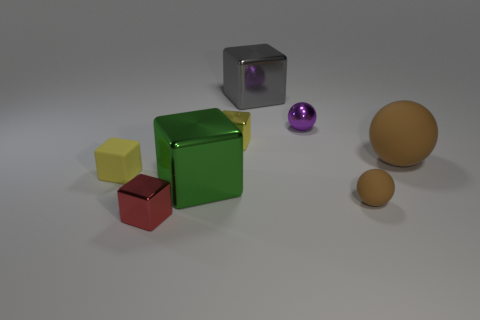Subtract 2 cubes. How many cubes are left? 3 Subtract all yellow balls. Subtract all gray cylinders. How many balls are left? 3 Add 2 tiny yellow matte things. How many objects exist? 10 Subtract all balls. How many objects are left? 5 Add 3 purple shiny balls. How many purple shiny balls exist? 4 Subtract 1 red cubes. How many objects are left? 7 Subtract all shiny cubes. Subtract all yellow things. How many objects are left? 2 Add 4 rubber balls. How many rubber balls are left? 6 